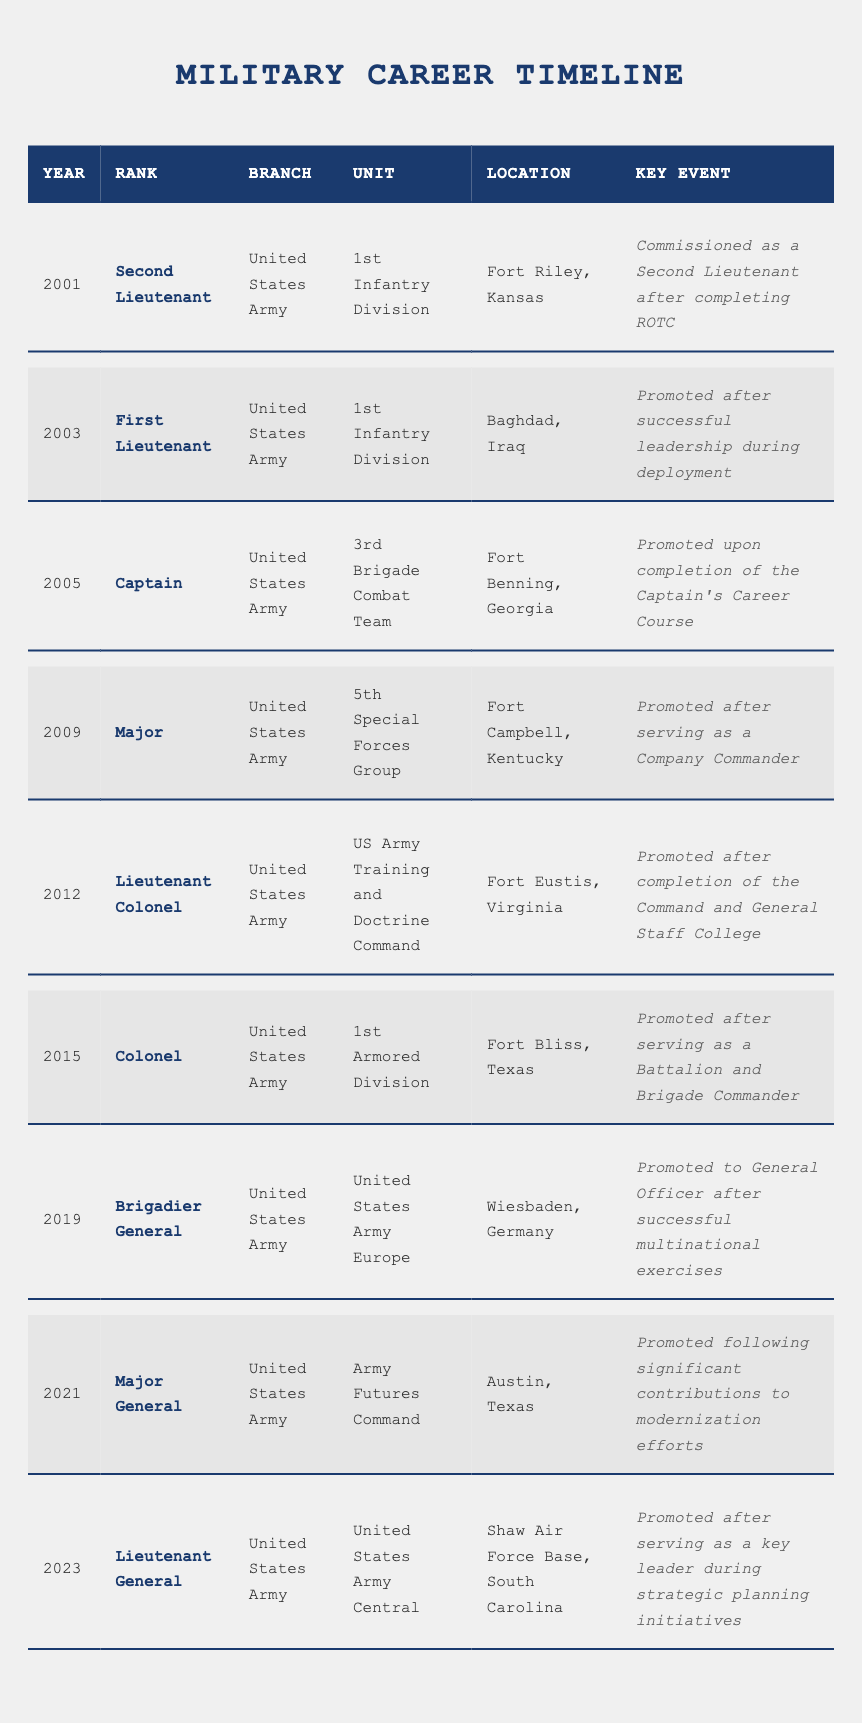What rank did the officer hold in 2005? The table shows that in 2005, the officer held the rank of Captain.
Answer: Captain Which branch did the officer serve in throughout their career? The table consistently lists the branch as the United States Army for all years and ranks.
Answer: United States Army What was the key event for the officer in 2015? According to the table, the key event in 2015 was the officer being promoted after serving as a Battalion and Brigade Commander.
Answer: Promoted after serving as a Battalion and Brigade Commander In which location was the officer promoted to Brigadier General? The location listed in the table for the promotion to Brigadier General in 2019 is Wiesbaden, Germany.
Answer: Wiesbaden, Germany How many ranks did the officer progress through from 2001 to 2023? The ranks listed from 2001 to 2023 are Second Lieutenant, First Lieutenant, Captain, Major, Lieutenant Colonel, Colonel, Brigadier General, Major General, and Lieutenant General—totaling 9 ranks.
Answer: 9 True or False: The officer was promoted to Major after completing the Captain’s Career Course. The table indicates that the officer was promoted to Major in 2009 after serving as a Company Commander, not after completing the Captain’s Career Course.
Answer: False What was the years' difference between the officer being promoted to Colonel and to Major General? The officer was promoted to Colonel in 2015 and to Major General in 2021, which is a difference of 6 years (2021 - 2015).
Answer: 6 years Which unit was the officer assigned to when they achieved the rank of Lieutenant Colonel? The table shows that the officer was assigned to the US Army Training and Doctrine Command at Fort Eustis, Virginia, when they achieved the rank of Lieutenant Colonel in 2012.
Answer: US Army Training and Doctrine Command What was the officer's rank immediately before the Lieutenant General? The table lists Major General as the rank immediately before Lieutenant General, which was achieved in 2021.
Answer: Major General In which year did the officer's rank transition from Colonel to Brigadier General? The table states that the rank transitioned from Colonel to Brigadier General in 2019.
Answer: 2019 Was there a gap of more than three years between any two promotions? Yes, there was a gap of four years between Major in 2009 and Lieutenant Colonel in 2012, making it more than three years.
Answer: Yes What was the significant contribution that led to the officer’s promotion to Major General? The table indicates that the significant contribution was modernizing efforts while at the Army Futures Command in 2021.
Answer: Modernization efforts How many different units did the officer serve in, and what are they? The officer served in the following units: 1st Infantry Division, 3rd Brigade Combat Team, 5th Special Forces Group, US Army Training and Doctrine Command, 1st Armored Division, United States Army Europe, and Army Futures Command—totaling 7 units.
Answer: 7 units: 1st Infantry Division, 3rd Brigade Combat Team, 5th Special Forces Group, US Army Training and Doctrine Command, 1st Armored Division, United States Army Europe, Army Futures Command What was the key event associated with the officer's promotion to Lieutenant General? The key event for the promotion to Lieutenant General in 2023 involved serving as a key leader during strategic planning initiatives.
Answer: Key leader during strategic planning initiatives 